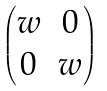<formula> <loc_0><loc_0><loc_500><loc_500>\begin{pmatrix} w & 0 \\ 0 & w \end{pmatrix}</formula> 